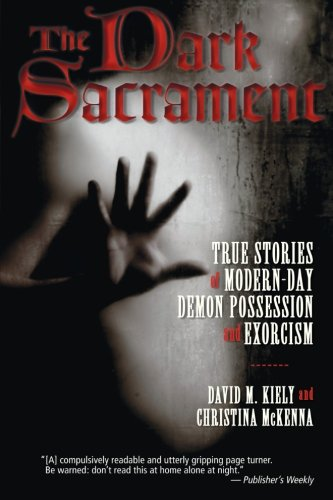Is this book related to Teen & Young Adult? No, given its intense and serious content, it is not aimed at the Teen & Young Adult audience. 